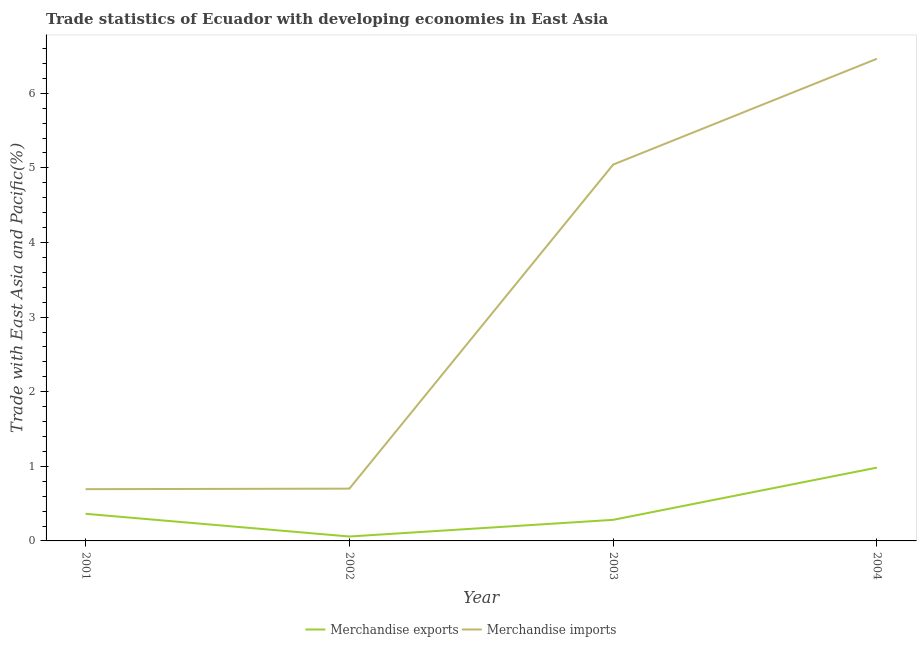How many different coloured lines are there?
Your response must be concise. 2. Does the line corresponding to merchandise exports intersect with the line corresponding to merchandise imports?
Offer a very short reply. No. What is the merchandise imports in 2003?
Your answer should be compact. 5.04. Across all years, what is the maximum merchandise exports?
Ensure brevity in your answer.  0.98. Across all years, what is the minimum merchandise exports?
Keep it short and to the point. 0.06. In which year was the merchandise exports maximum?
Make the answer very short. 2004. What is the total merchandise imports in the graph?
Your answer should be very brief. 12.9. What is the difference between the merchandise imports in 2002 and that in 2004?
Give a very brief answer. -5.76. What is the difference between the merchandise imports in 2004 and the merchandise exports in 2001?
Your answer should be compact. 6.1. What is the average merchandise exports per year?
Make the answer very short. 0.42. In the year 2004, what is the difference between the merchandise imports and merchandise exports?
Provide a short and direct response. 5.48. What is the ratio of the merchandise imports in 2001 to that in 2002?
Your answer should be very brief. 0.99. What is the difference between the highest and the second highest merchandise exports?
Provide a succinct answer. 0.62. What is the difference between the highest and the lowest merchandise exports?
Your response must be concise. 0.92. Is the sum of the merchandise imports in 2001 and 2004 greater than the maximum merchandise exports across all years?
Your answer should be very brief. Yes. Does the merchandise imports monotonically increase over the years?
Give a very brief answer. Yes. Is the merchandise imports strictly greater than the merchandise exports over the years?
Offer a terse response. Yes. Is the merchandise exports strictly less than the merchandise imports over the years?
Ensure brevity in your answer.  Yes. How many years are there in the graph?
Give a very brief answer. 4. What is the difference between two consecutive major ticks on the Y-axis?
Offer a terse response. 1. Are the values on the major ticks of Y-axis written in scientific E-notation?
Make the answer very short. No. Does the graph contain any zero values?
Offer a very short reply. No. Does the graph contain grids?
Your response must be concise. No. How many legend labels are there?
Offer a terse response. 2. What is the title of the graph?
Provide a succinct answer. Trade statistics of Ecuador with developing economies in East Asia. What is the label or title of the Y-axis?
Offer a terse response. Trade with East Asia and Pacific(%). What is the Trade with East Asia and Pacific(%) of Merchandise exports in 2001?
Provide a succinct answer. 0.36. What is the Trade with East Asia and Pacific(%) in Merchandise imports in 2001?
Your answer should be very brief. 0.69. What is the Trade with East Asia and Pacific(%) of Merchandise exports in 2002?
Ensure brevity in your answer.  0.06. What is the Trade with East Asia and Pacific(%) of Merchandise imports in 2002?
Give a very brief answer. 0.7. What is the Trade with East Asia and Pacific(%) of Merchandise exports in 2003?
Ensure brevity in your answer.  0.28. What is the Trade with East Asia and Pacific(%) of Merchandise imports in 2003?
Provide a short and direct response. 5.04. What is the Trade with East Asia and Pacific(%) in Merchandise exports in 2004?
Provide a succinct answer. 0.98. What is the Trade with East Asia and Pacific(%) of Merchandise imports in 2004?
Provide a succinct answer. 6.46. Across all years, what is the maximum Trade with East Asia and Pacific(%) in Merchandise exports?
Your answer should be very brief. 0.98. Across all years, what is the maximum Trade with East Asia and Pacific(%) of Merchandise imports?
Provide a succinct answer. 6.46. Across all years, what is the minimum Trade with East Asia and Pacific(%) of Merchandise exports?
Your response must be concise. 0.06. Across all years, what is the minimum Trade with East Asia and Pacific(%) of Merchandise imports?
Keep it short and to the point. 0.69. What is the total Trade with East Asia and Pacific(%) in Merchandise exports in the graph?
Offer a very short reply. 1.69. What is the total Trade with East Asia and Pacific(%) of Merchandise imports in the graph?
Give a very brief answer. 12.9. What is the difference between the Trade with East Asia and Pacific(%) of Merchandise exports in 2001 and that in 2002?
Offer a very short reply. 0.3. What is the difference between the Trade with East Asia and Pacific(%) in Merchandise imports in 2001 and that in 2002?
Your answer should be compact. -0.01. What is the difference between the Trade with East Asia and Pacific(%) in Merchandise exports in 2001 and that in 2003?
Provide a short and direct response. 0.08. What is the difference between the Trade with East Asia and Pacific(%) in Merchandise imports in 2001 and that in 2003?
Offer a terse response. -4.35. What is the difference between the Trade with East Asia and Pacific(%) in Merchandise exports in 2001 and that in 2004?
Provide a succinct answer. -0.62. What is the difference between the Trade with East Asia and Pacific(%) of Merchandise imports in 2001 and that in 2004?
Make the answer very short. -5.77. What is the difference between the Trade with East Asia and Pacific(%) of Merchandise exports in 2002 and that in 2003?
Your answer should be very brief. -0.22. What is the difference between the Trade with East Asia and Pacific(%) in Merchandise imports in 2002 and that in 2003?
Provide a succinct answer. -4.34. What is the difference between the Trade with East Asia and Pacific(%) in Merchandise exports in 2002 and that in 2004?
Your answer should be very brief. -0.92. What is the difference between the Trade with East Asia and Pacific(%) of Merchandise imports in 2002 and that in 2004?
Your response must be concise. -5.76. What is the difference between the Trade with East Asia and Pacific(%) in Merchandise exports in 2003 and that in 2004?
Your answer should be compact. -0.7. What is the difference between the Trade with East Asia and Pacific(%) of Merchandise imports in 2003 and that in 2004?
Provide a short and direct response. -1.42. What is the difference between the Trade with East Asia and Pacific(%) in Merchandise exports in 2001 and the Trade with East Asia and Pacific(%) in Merchandise imports in 2002?
Ensure brevity in your answer.  -0.34. What is the difference between the Trade with East Asia and Pacific(%) in Merchandise exports in 2001 and the Trade with East Asia and Pacific(%) in Merchandise imports in 2003?
Provide a succinct answer. -4.68. What is the difference between the Trade with East Asia and Pacific(%) of Merchandise exports in 2001 and the Trade with East Asia and Pacific(%) of Merchandise imports in 2004?
Provide a succinct answer. -6.1. What is the difference between the Trade with East Asia and Pacific(%) in Merchandise exports in 2002 and the Trade with East Asia and Pacific(%) in Merchandise imports in 2003?
Offer a very short reply. -4.99. What is the difference between the Trade with East Asia and Pacific(%) in Merchandise exports in 2002 and the Trade with East Asia and Pacific(%) in Merchandise imports in 2004?
Offer a very short reply. -6.4. What is the difference between the Trade with East Asia and Pacific(%) of Merchandise exports in 2003 and the Trade with East Asia and Pacific(%) of Merchandise imports in 2004?
Provide a short and direct response. -6.18. What is the average Trade with East Asia and Pacific(%) of Merchandise exports per year?
Provide a short and direct response. 0.42. What is the average Trade with East Asia and Pacific(%) of Merchandise imports per year?
Give a very brief answer. 3.23. In the year 2001, what is the difference between the Trade with East Asia and Pacific(%) in Merchandise exports and Trade with East Asia and Pacific(%) in Merchandise imports?
Your response must be concise. -0.33. In the year 2002, what is the difference between the Trade with East Asia and Pacific(%) of Merchandise exports and Trade with East Asia and Pacific(%) of Merchandise imports?
Your answer should be very brief. -0.64. In the year 2003, what is the difference between the Trade with East Asia and Pacific(%) of Merchandise exports and Trade with East Asia and Pacific(%) of Merchandise imports?
Provide a short and direct response. -4.76. In the year 2004, what is the difference between the Trade with East Asia and Pacific(%) of Merchandise exports and Trade with East Asia and Pacific(%) of Merchandise imports?
Offer a terse response. -5.48. What is the ratio of the Trade with East Asia and Pacific(%) in Merchandise exports in 2001 to that in 2002?
Make the answer very short. 6.14. What is the ratio of the Trade with East Asia and Pacific(%) of Merchandise imports in 2001 to that in 2002?
Provide a succinct answer. 0.99. What is the ratio of the Trade with East Asia and Pacific(%) in Merchandise exports in 2001 to that in 2003?
Give a very brief answer. 1.29. What is the ratio of the Trade with East Asia and Pacific(%) of Merchandise imports in 2001 to that in 2003?
Your response must be concise. 0.14. What is the ratio of the Trade with East Asia and Pacific(%) of Merchandise exports in 2001 to that in 2004?
Ensure brevity in your answer.  0.37. What is the ratio of the Trade with East Asia and Pacific(%) of Merchandise imports in 2001 to that in 2004?
Provide a short and direct response. 0.11. What is the ratio of the Trade with East Asia and Pacific(%) in Merchandise exports in 2002 to that in 2003?
Ensure brevity in your answer.  0.21. What is the ratio of the Trade with East Asia and Pacific(%) of Merchandise imports in 2002 to that in 2003?
Offer a terse response. 0.14. What is the ratio of the Trade with East Asia and Pacific(%) of Merchandise exports in 2002 to that in 2004?
Provide a short and direct response. 0.06. What is the ratio of the Trade with East Asia and Pacific(%) of Merchandise imports in 2002 to that in 2004?
Your response must be concise. 0.11. What is the ratio of the Trade with East Asia and Pacific(%) in Merchandise exports in 2003 to that in 2004?
Keep it short and to the point. 0.29. What is the ratio of the Trade with East Asia and Pacific(%) in Merchandise imports in 2003 to that in 2004?
Your answer should be very brief. 0.78. What is the difference between the highest and the second highest Trade with East Asia and Pacific(%) in Merchandise exports?
Offer a terse response. 0.62. What is the difference between the highest and the second highest Trade with East Asia and Pacific(%) in Merchandise imports?
Give a very brief answer. 1.42. What is the difference between the highest and the lowest Trade with East Asia and Pacific(%) in Merchandise exports?
Give a very brief answer. 0.92. What is the difference between the highest and the lowest Trade with East Asia and Pacific(%) in Merchandise imports?
Keep it short and to the point. 5.77. 